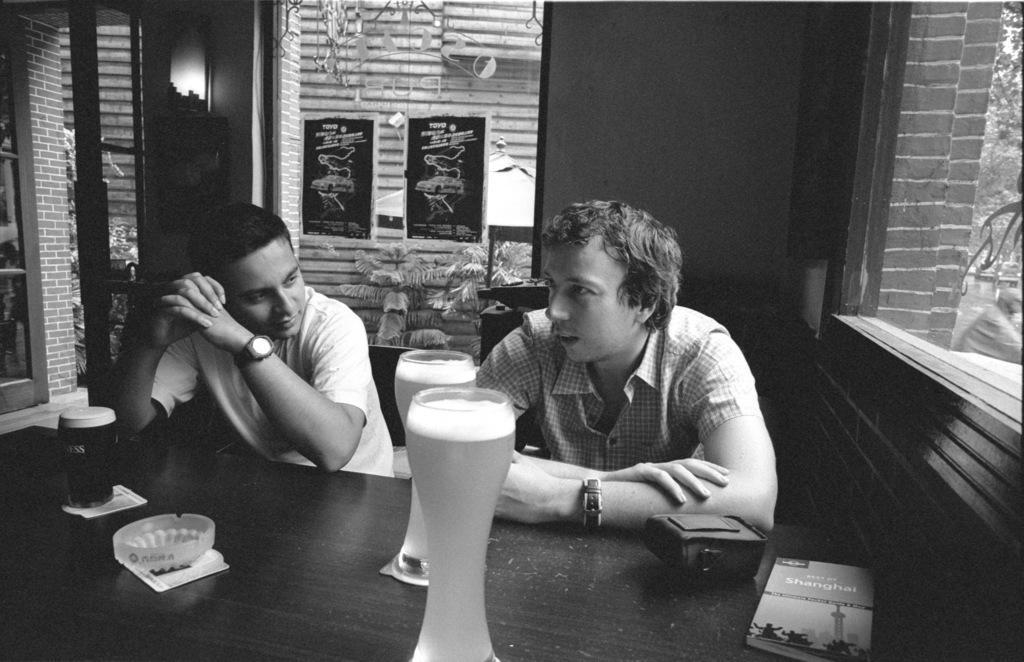Can you describe this image briefly? The person is sitting on a chair and there is a table in front of them which has a glass of wine and some other objects on it. 